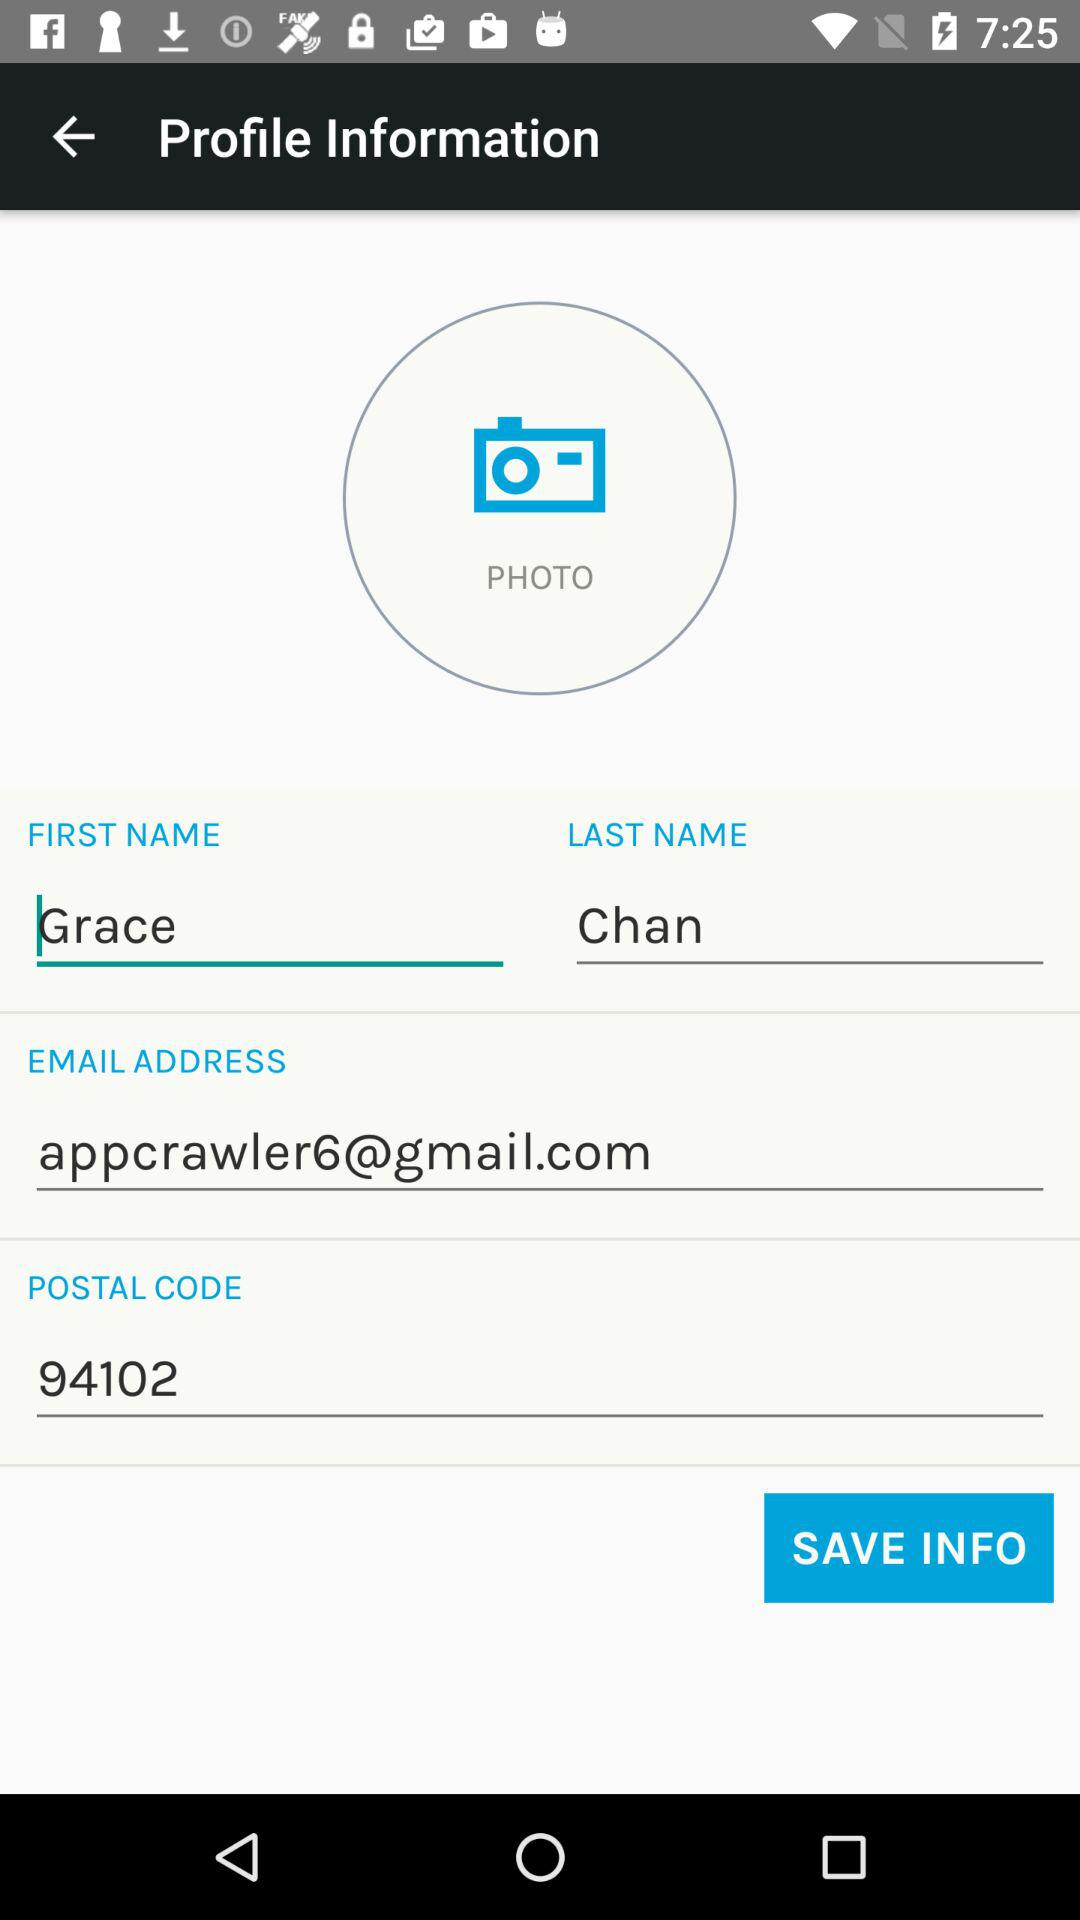What is the email address? The email address is appcrawler6@gmail.com. 